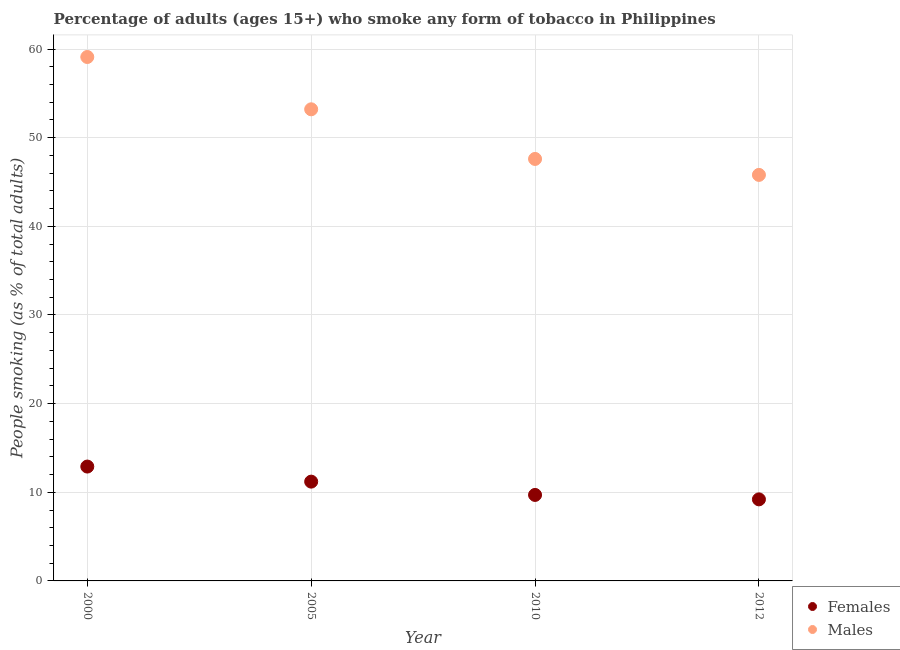How many different coloured dotlines are there?
Make the answer very short. 2. Is the number of dotlines equal to the number of legend labels?
Provide a succinct answer. Yes. What is the percentage of males who smoke in 2000?
Your answer should be compact. 59.1. Across all years, what is the maximum percentage of males who smoke?
Your response must be concise. 59.1. Across all years, what is the minimum percentage of males who smoke?
Make the answer very short. 45.8. What is the difference between the percentage of males who smoke in 2000 and that in 2012?
Your answer should be very brief. 13.3. What is the difference between the percentage of females who smoke in 2000 and the percentage of males who smoke in 2005?
Offer a terse response. -40.3. What is the average percentage of females who smoke per year?
Make the answer very short. 10.75. In the year 2010, what is the difference between the percentage of females who smoke and percentage of males who smoke?
Ensure brevity in your answer.  -37.9. In how many years, is the percentage of males who smoke greater than 24 %?
Give a very brief answer. 4. What is the ratio of the percentage of females who smoke in 2010 to that in 2012?
Offer a terse response. 1.05. Is the percentage of males who smoke in 2005 less than that in 2012?
Make the answer very short. No. Is the difference between the percentage of females who smoke in 2010 and 2012 greater than the difference between the percentage of males who smoke in 2010 and 2012?
Ensure brevity in your answer.  No. What is the difference between the highest and the second highest percentage of females who smoke?
Provide a short and direct response. 1.7. What is the difference between the highest and the lowest percentage of females who smoke?
Ensure brevity in your answer.  3.7. In how many years, is the percentage of males who smoke greater than the average percentage of males who smoke taken over all years?
Provide a succinct answer. 2. Is the sum of the percentage of males who smoke in 2005 and 2012 greater than the maximum percentage of females who smoke across all years?
Offer a very short reply. Yes. Is the percentage of males who smoke strictly greater than the percentage of females who smoke over the years?
Your answer should be compact. Yes. Is the percentage of females who smoke strictly less than the percentage of males who smoke over the years?
Your response must be concise. Yes. What is the difference between two consecutive major ticks on the Y-axis?
Offer a very short reply. 10. Does the graph contain any zero values?
Ensure brevity in your answer.  No. Does the graph contain grids?
Provide a short and direct response. Yes. Where does the legend appear in the graph?
Offer a terse response. Bottom right. How many legend labels are there?
Offer a very short reply. 2. What is the title of the graph?
Provide a short and direct response. Percentage of adults (ages 15+) who smoke any form of tobacco in Philippines. Does "GDP at market prices" appear as one of the legend labels in the graph?
Make the answer very short. No. What is the label or title of the X-axis?
Provide a short and direct response. Year. What is the label or title of the Y-axis?
Your answer should be very brief. People smoking (as % of total adults). What is the People smoking (as % of total adults) of Females in 2000?
Your answer should be very brief. 12.9. What is the People smoking (as % of total adults) in Males in 2000?
Offer a terse response. 59.1. What is the People smoking (as % of total adults) of Females in 2005?
Your answer should be compact. 11.2. What is the People smoking (as % of total adults) of Males in 2005?
Make the answer very short. 53.2. What is the People smoking (as % of total adults) of Males in 2010?
Keep it short and to the point. 47.6. What is the People smoking (as % of total adults) of Males in 2012?
Provide a short and direct response. 45.8. Across all years, what is the maximum People smoking (as % of total adults) in Females?
Offer a terse response. 12.9. Across all years, what is the maximum People smoking (as % of total adults) of Males?
Give a very brief answer. 59.1. Across all years, what is the minimum People smoking (as % of total adults) in Males?
Provide a short and direct response. 45.8. What is the total People smoking (as % of total adults) in Females in the graph?
Ensure brevity in your answer.  43. What is the total People smoking (as % of total adults) in Males in the graph?
Keep it short and to the point. 205.7. What is the difference between the People smoking (as % of total adults) of Females in 2000 and that in 2005?
Provide a short and direct response. 1.7. What is the difference between the People smoking (as % of total adults) of Males in 2000 and that in 2005?
Provide a succinct answer. 5.9. What is the difference between the People smoking (as % of total adults) in Females in 2005 and that in 2010?
Provide a short and direct response. 1.5. What is the difference between the People smoking (as % of total adults) in Males in 2005 and that in 2010?
Make the answer very short. 5.6. What is the difference between the People smoking (as % of total adults) of Males in 2005 and that in 2012?
Your answer should be very brief. 7.4. What is the difference between the People smoking (as % of total adults) of Females in 2000 and the People smoking (as % of total adults) of Males in 2005?
Keep it short and to the point. -40.3. What is the difference between the People smoking (as % of total adults) in Females in 2000 and the People smoking (as % of total adults) in Males in 2010?
Offer a very short reply. -34.7. What is the difference between the People smoking (as % of total adults) of Females in 2000 and the People smoking (as % of total adults) of Males in 2012?
Your answer should be compact. -32.9. What is the difference between the People smoking (as % of total adults) of Females in 2005 and the People smoking (as % of total adults) of Males in 2010?
Your answer should be compact. -36.4. What is the difference between the People smoking (as % of total adults) in Females in 2005 and the People smoking (as % of total adults) in Males in 2012?
Offer a terse response. -34.6. What is the difference between the People smoking (as % of total adults) of Females in 2010 and the People smoking (as % of total adults) of Males in 2012?
Make the answer very short. -36.1. What is the average People smoking (as % of total adults) of Females per year?
Your answer should be compact. 10.75. What is the average People smoking (as % of total adults) in Males per year?
Your response must be concise. 51.42. In the year 2000, what is the difference between the People smoking (as % of total adults) in Females and People smoking (as % of total adults) in Males?
Your answer should be compact. -46.2. In the year 2005, what is the difference between the People smoking (as % of total adults) of Females and People smoking (as % of total adults) of Males?
Make the answer very short. -42. In the year 2010, what is the difference between the People smoking (as % of total adults) in Females and People smoking (as % of total adults) in Males?
Your answer should be compact. -37.9. In the year 2012, what is the difference between the People smoking (as % of total adults) of Females and People smoking (as % of total adults) of Males?
Offer a terse response. -36.6. What is the ratio of the People smoking (as % of total adults) in Females in 2000 to that in 2005?
Provide a short and direct response. 1.15. What is the ratio of the People smoking (as % of total adults) in Males in 2000 to that in 2005?
Provide a succinct answer. 1.11. What is the ratio of the People smoking (as % of total adults) in Females in 2000 to that in 2010?
Keep it short and to the point. 1.33. What is the ratio of the People smoking (as % of total adults) in Males in 2000 to that in 2010?
Your response must be concise. 1.24. What is the ratio of the People smoking (as % of total adults) of Females in 2000 to that in 2012?
Your response must be concise. 1.4. What is the ratio of the People smoking (as % of total adults) in Males in 2000 to that in 2012?
Provide a succinct answer. 1.29. What is the ratio of the People smoking (as % of total adults) of Females in 2005 to that in 2010?
Offer a very short reply. 1.15. What is the ratio of the People smoking (as % of total adults) of Males in 2005 to that in 2010?
Your response must be concise. 1.12. What is the ratio of the People smoking (as % of total adults) of Females in 2005 to that in 2012?
Keep it short and to the point. 1.22. What is the ratio of the People smoking (as % of total adults) in Males in 2005 to that in 2012?
Offer a terse response. 1.16. What is the ratio of the People smoking (as % of total adults) in Females in 2010 to that in 2012?
Ensure brevity in your answer.  1.05. What is the ratio of the People smoking (as % of total adults) in Males in 2010 to that in 2012?
Your answer should be compact. 1.04. What is the difference between the highest and the second highest People smoking (as % of total adults) of Males?
Offer a very short reply. 5.9. What is the difference between the highest and the lowest People smoking (as % of total adults) of Females?
Your answer should be very brief. 3.7. 